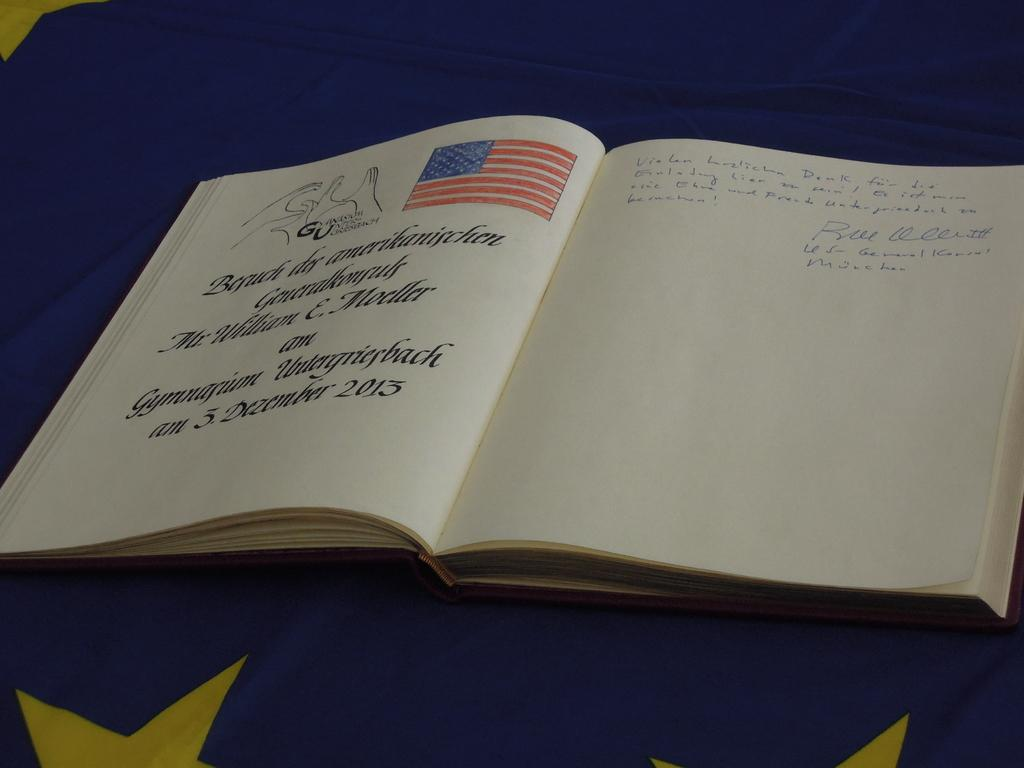What is the main object in the image? There is a book in the image. What type of content does the book have? The book contains pictures and text. What is the book placed on? The book is placed on a cloth. What type of street is visible in the image? There is no street visible in the image; it features a book with pictures and text placed on a cloth. How many cards are present in the image? There are no cards present in the image; it features a book with pictures and text placed on a cloth. 